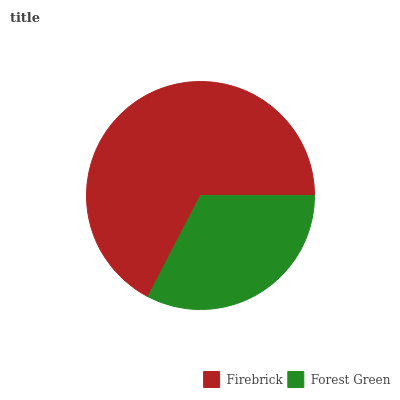Is Forest Green the minimum?
Answer yes or no. Yes. Is Firebrick the maximum?
Answer yes or no. Yes. Is Forest Green the maximum?
Answer yes or no. No. Is Firebrick greater than Forest Green?
Answer yes or no. Yes. Is Forest Green less than Firebrick?
Answer yes or no. Yes. Is Forest Green greater than Firebrick?
Answer yes or no. No. Is Firebrick less than Forest Green?
Answer yes or no. No. Is Firebrick the high median?
Answer yes or no. Yes. Is Forest Green the low median?
Answer yes or no. Yes. Is Forest Green the high median?
Answer yes or no. No. Is Firebrick the low median?
Answer yes or no. No. 